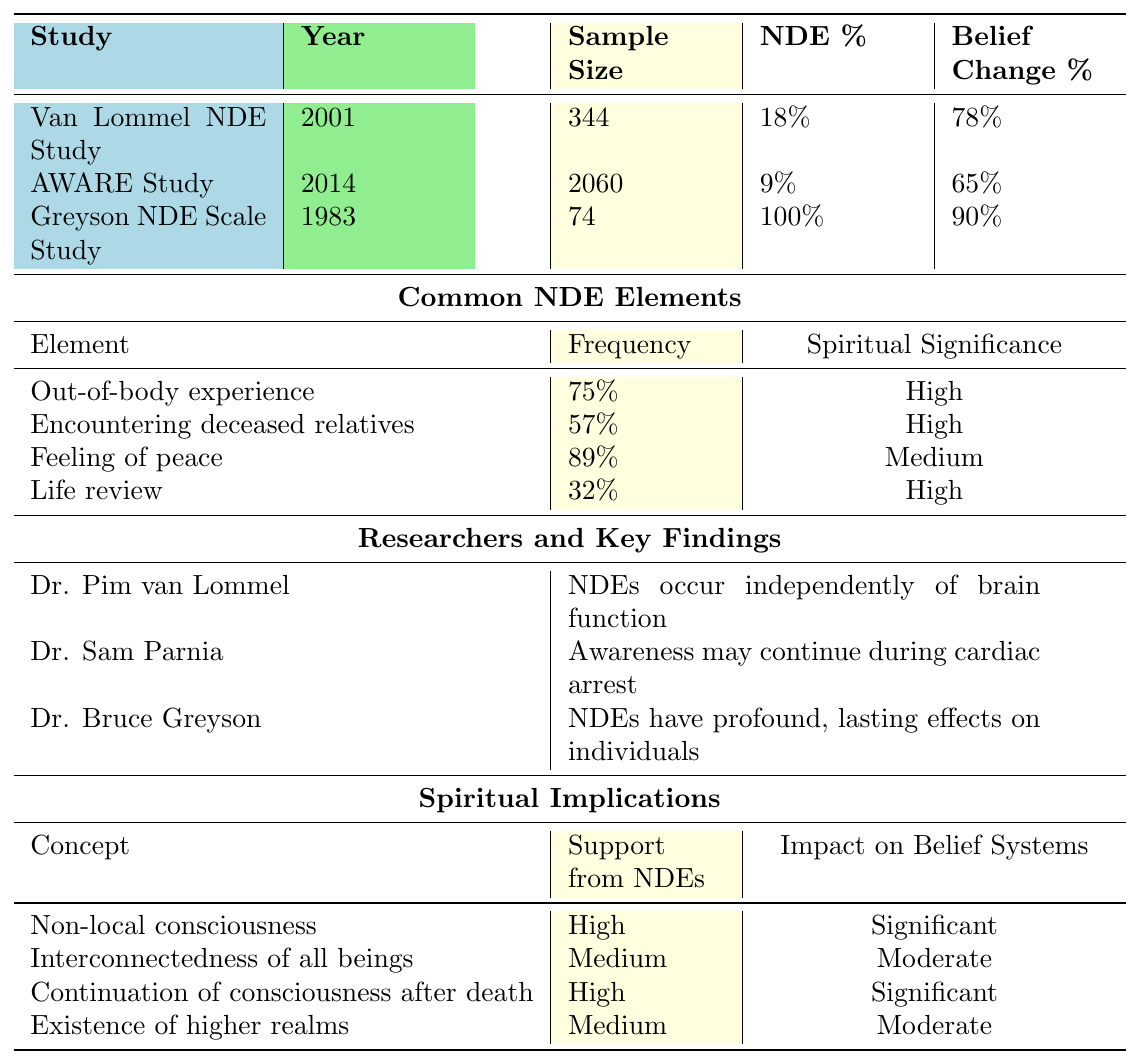What is the reported percentage of near-death experiences in the Greyson NDE Scale Study? According to the table, the Greyson NDE Scale Study reported a near-death experience percentage of 100%.
Answer: 100% Which study has the largest sample size, and what is that size? The AWARE Study has the largest sample size at 2060 participants according to the information in the table.
Answer: 2060 What portion of participants in the Van Lommel NDE Study reported a change in beliefs? The table shows that 78% of participants in the Van Lommel NDE Study reported a change in beliefs.
Answer: 78% How many NDE elements have a spiritual significance rated as high? There are 3 NDE elements in the table that have a spiritual significance rated as high: Out-of-body experience, Encountering deceased relatives, and Life review.
Answer: 3 Which researchers found high support for non-local consciousness from near-death experiences? According to the table, Dr. Pim van Lommel and Dr. Bruce Greyson both found high support for non-local consciousness from near-death experiences.
Answer: Dr. Pim van Lommel, Dr. Bruce Greyson What is the average reported belief change percentage across all studies listed? To find the average, add the belief change percentages: 78 + 65 + 90 = 233. Then divide by the number of studies, which is 3: 233/3 = 77.67. Rounding results gives an average belief change of approximately 78%.
Answer: 78% Do all studies indicate an improvement in spiritual outlook among participants? Yes, all studies listed in the table indicate an improved spiritual outlook, as each has a "true" designation under that category.
Answer: Yes Which near-death experience element has the highest frequency reported, and what is that frequency? The element with the highest frequency reported is the Feeling of peace at 89%.
Answer: 89% In which year was the study with the lowest percentage of reported near-death experiences conducted? The table indicates that the AWARE Study in 2014 had the lowest reported near-death experience percentage at 9%.
Answer: 2014 How does the spiritual significance of "Feeling of peace" compare to that of "Life review"? The spiritual significance of "Feeling of peace" is rated as medium, while "Life review" is rated as high. This indicates that "Life review" has greater spiritual significance than "Feeling of peace."
Answer: "Life review" is rated higher What impact do near-death experiences have on belief systems regarding the continuation of consciousness after death? The table states that near-death experiences provide high support for the continuation of consciousness after death, which significantly impacts belief systems on this subject.
Answer: Significant impact 